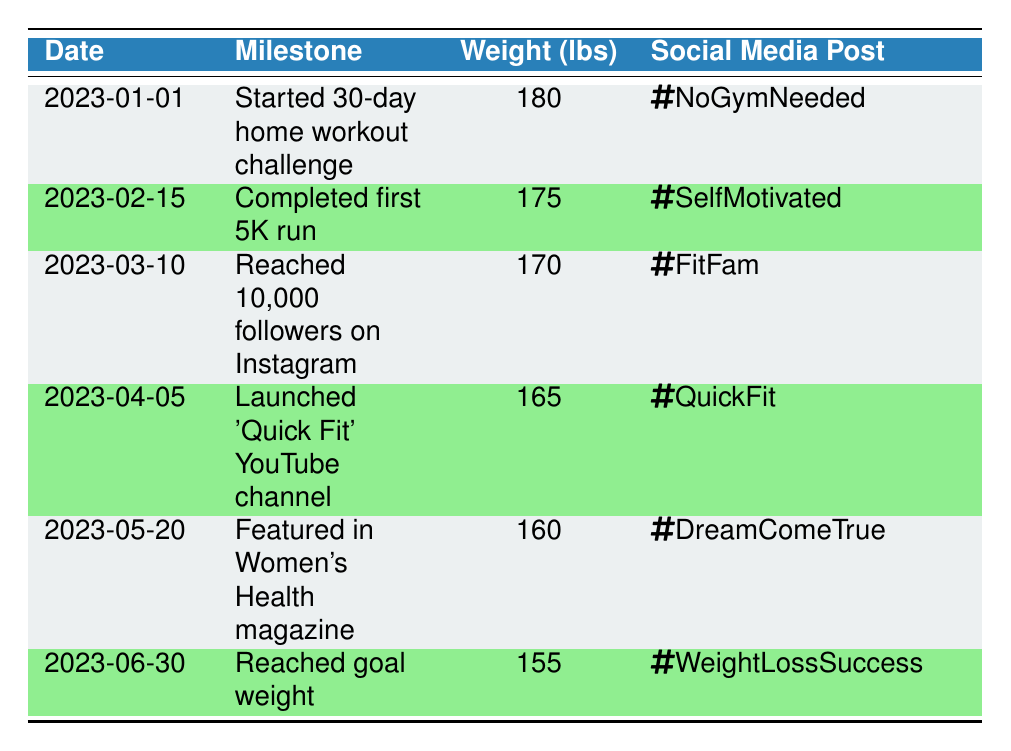What was the weight on February 15, 2023? The table shows that on February 15, 2023, the recorded weight was 175 pounds.
Answer: 175 What milestone was achieved on April 5, 2023? On April 5, 2023, the milestone achieved was the launch of the 'Quick Fit' YouTube channel.
Answer: Launched 'Quick Fit' YouTube channel How much weight was lost from January 1 to June 30? The weight on January 1 was 180 pounds, and by June 30, it was 155 pounds. The difference is 180 - 155 = 25 pounds lost over the period.
Answer: 25 pounds Was the first 5K run completed before reaching 10,000 Instagram followers? According to the table, the first 5K run was completed on February 15, 2023, and the milestone of reaching 10,000 followers was on March 10, 2023, confirming that the run was completed before this milestone.
Answer: Yes On which date was the milestone of reaching goal weight achieved? The table indicates that the goal weight was reached on June 30, 2023.
Answer: June 30, 2023 What is the average weight recorded over the timeline? The weights recorded were 180, 175, 170, 165, 160, and 155. To find the average, sum these values (180 + 175 + 170 + 165 + 160 + 155 = 1105) and then divide by the number of entries (6). Thus, 1105 / 6 = approximately 184.17 pounds.
Answer: Approximately 184.17 pounds Did the individual win an award, such as being featured in a magazine, during their journey? The table shows that on May 20, 2023, there was a feature in Women's Health magazine, indicating recognition for their journey.
Answer: Yes What social media hashtag was used to promote the 30-day workout challenge? The table lists the hashtag used for the 30-day workout challenge on January 1, 2023, as #NoGymNeeded.
Answer: #NoGymNeeded What was the milestone achieved closest to May 20, 2023? The closest milestone to May 20, 2023, is the launch of the 'Quick Fit' YouTube channel, which occurred on April 5, 2023.
Answer: Launched 'Quick Fit' YouTube channel 